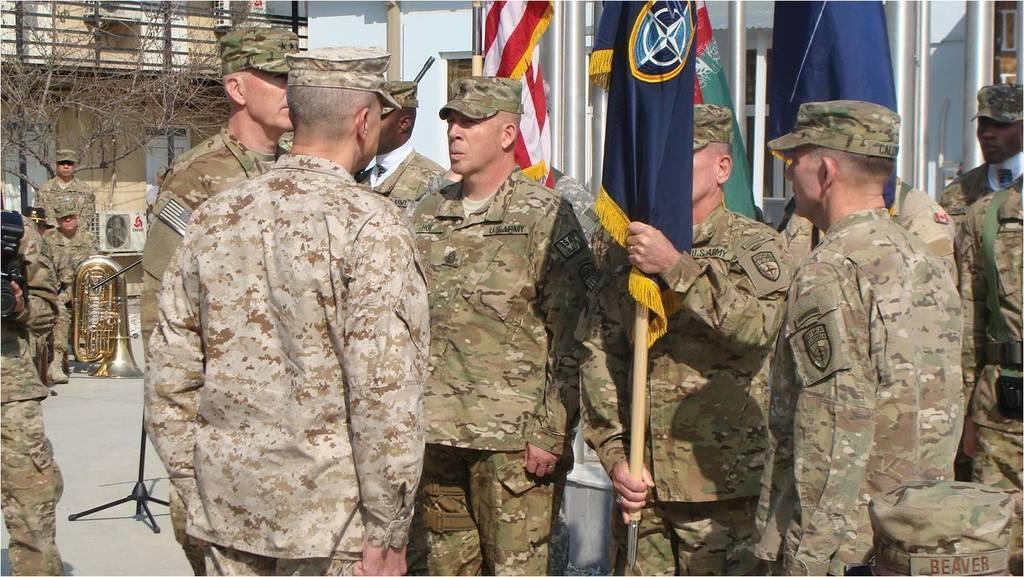How would you summarize this image in a sentence or two? In this image we can see people standing. They are wearing uniforms. The man standing in the center is holding a flag in his hand. In the background there are trees, buildings, poles and flags. On the left we can see a musical instrument. 